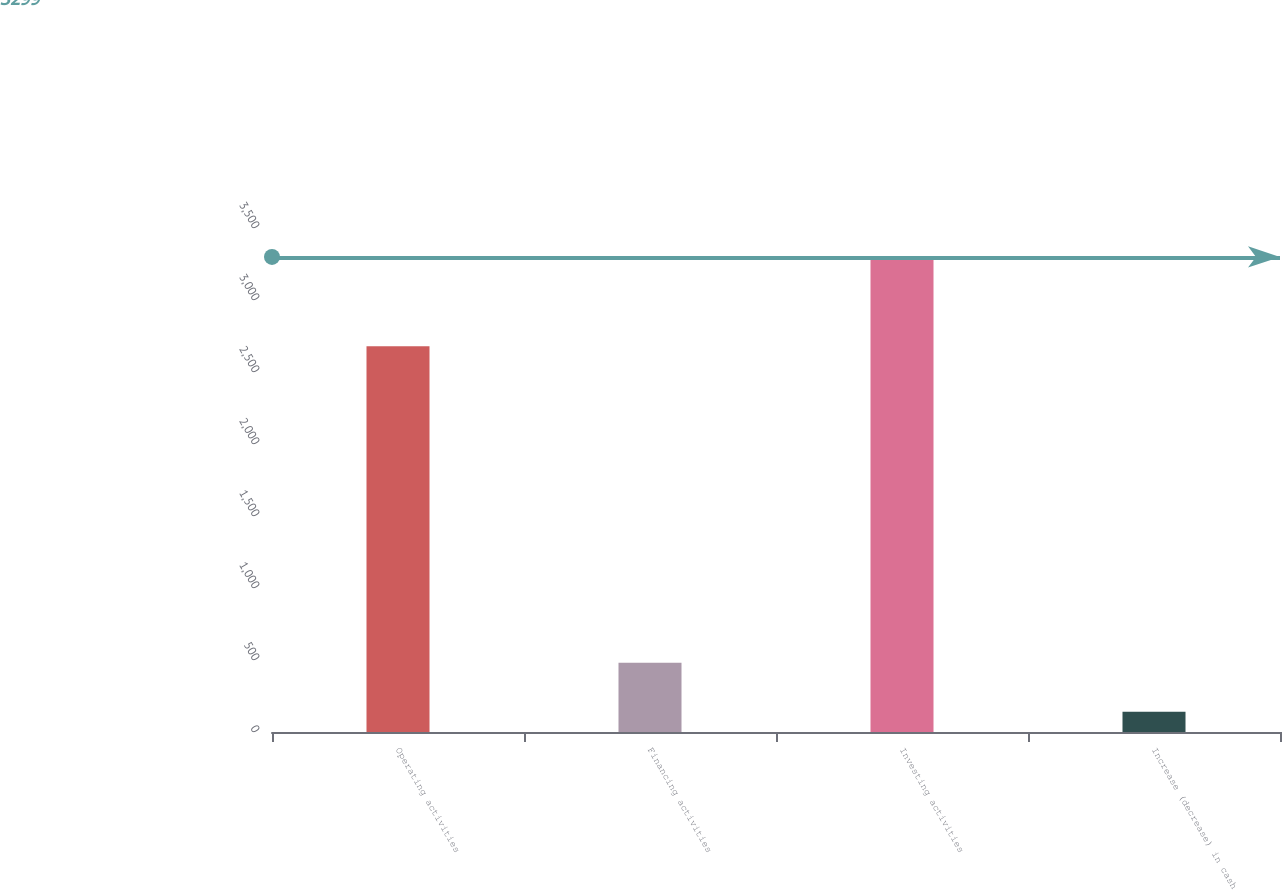Convert chart to OTSL. <chart><loc_0><loc_0><loc_500><loc_500><bar_chart><fcel>Operating activities<fcel>Financing activities<fcel>Investing activities<fcel>Increase (decrease) in cash<nl><fcel>2678<fcel>481<fcel>3299<fcel>140<nl></chart> 